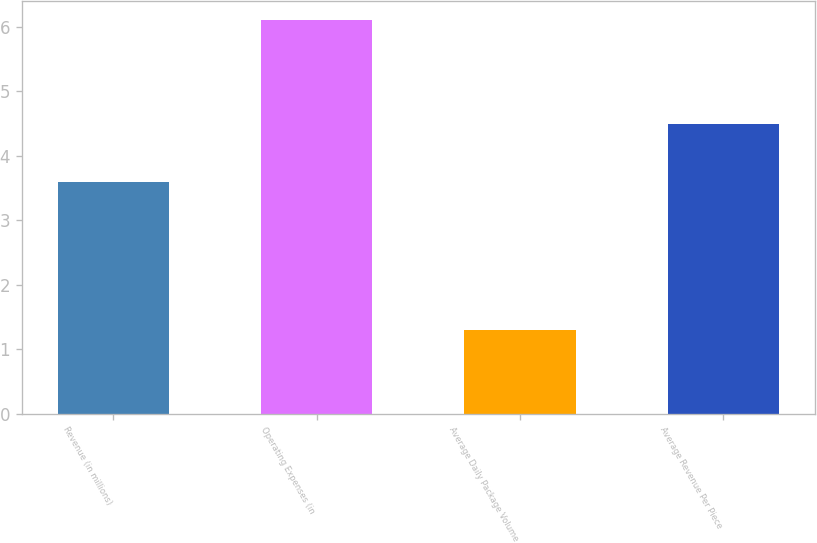Convert chart to OTSL. <chart><loc_0><loc_0><loc_500><loc_500><bar_chart><fcel>Revenue (in millions)<fcel>Operating Expenses (in<fcel>Average Daily Package Volume<fcel>Average Revenue Per Piece<nl><fcel>3.6<fcel>6.1<fcel>1.3<fcel>4.5<nl></chart> 